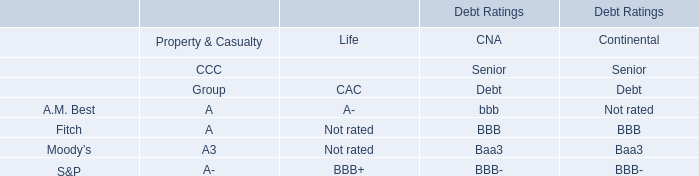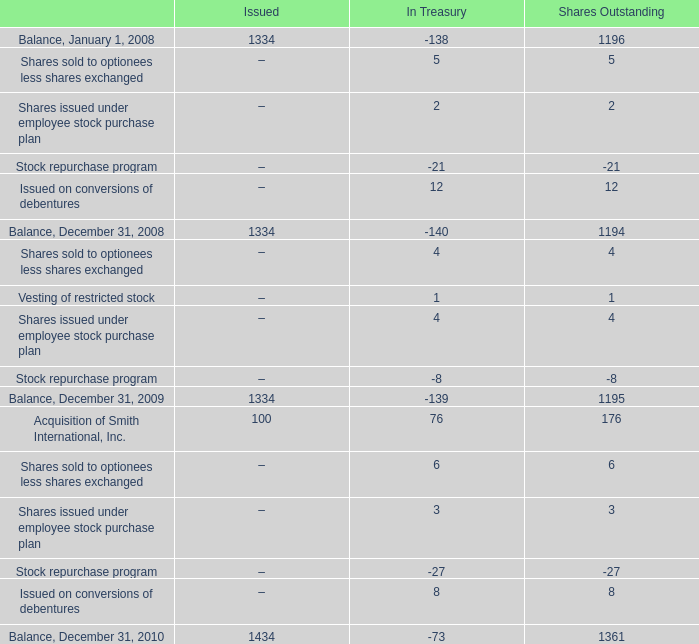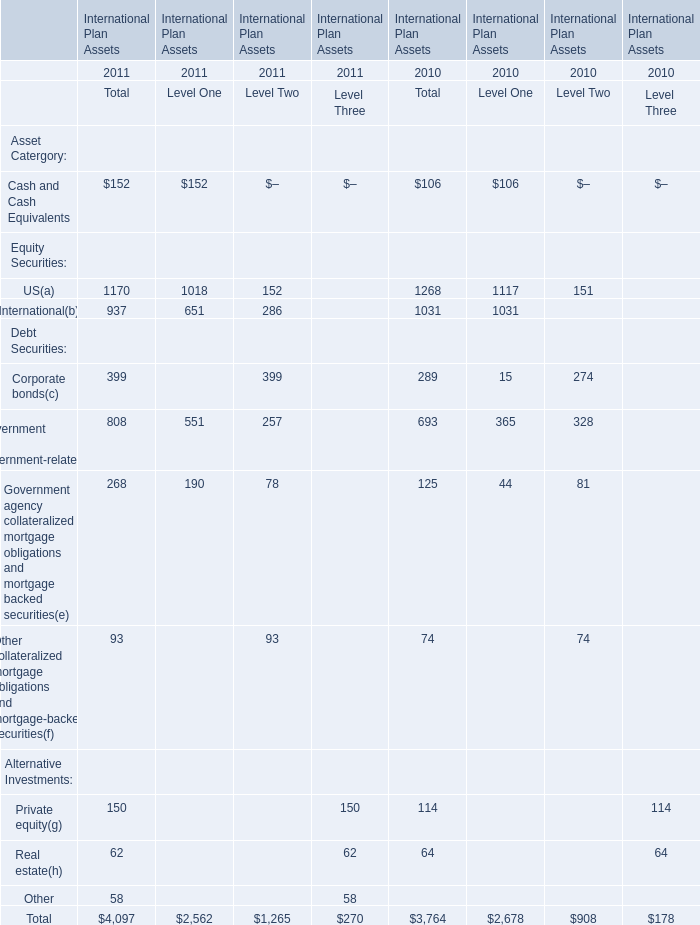what was the average beginning and ending balance of shares in millions outstanding during 2010? 
Computations: ((1361 + 1195) / 2)
Answer: 1278.0. 